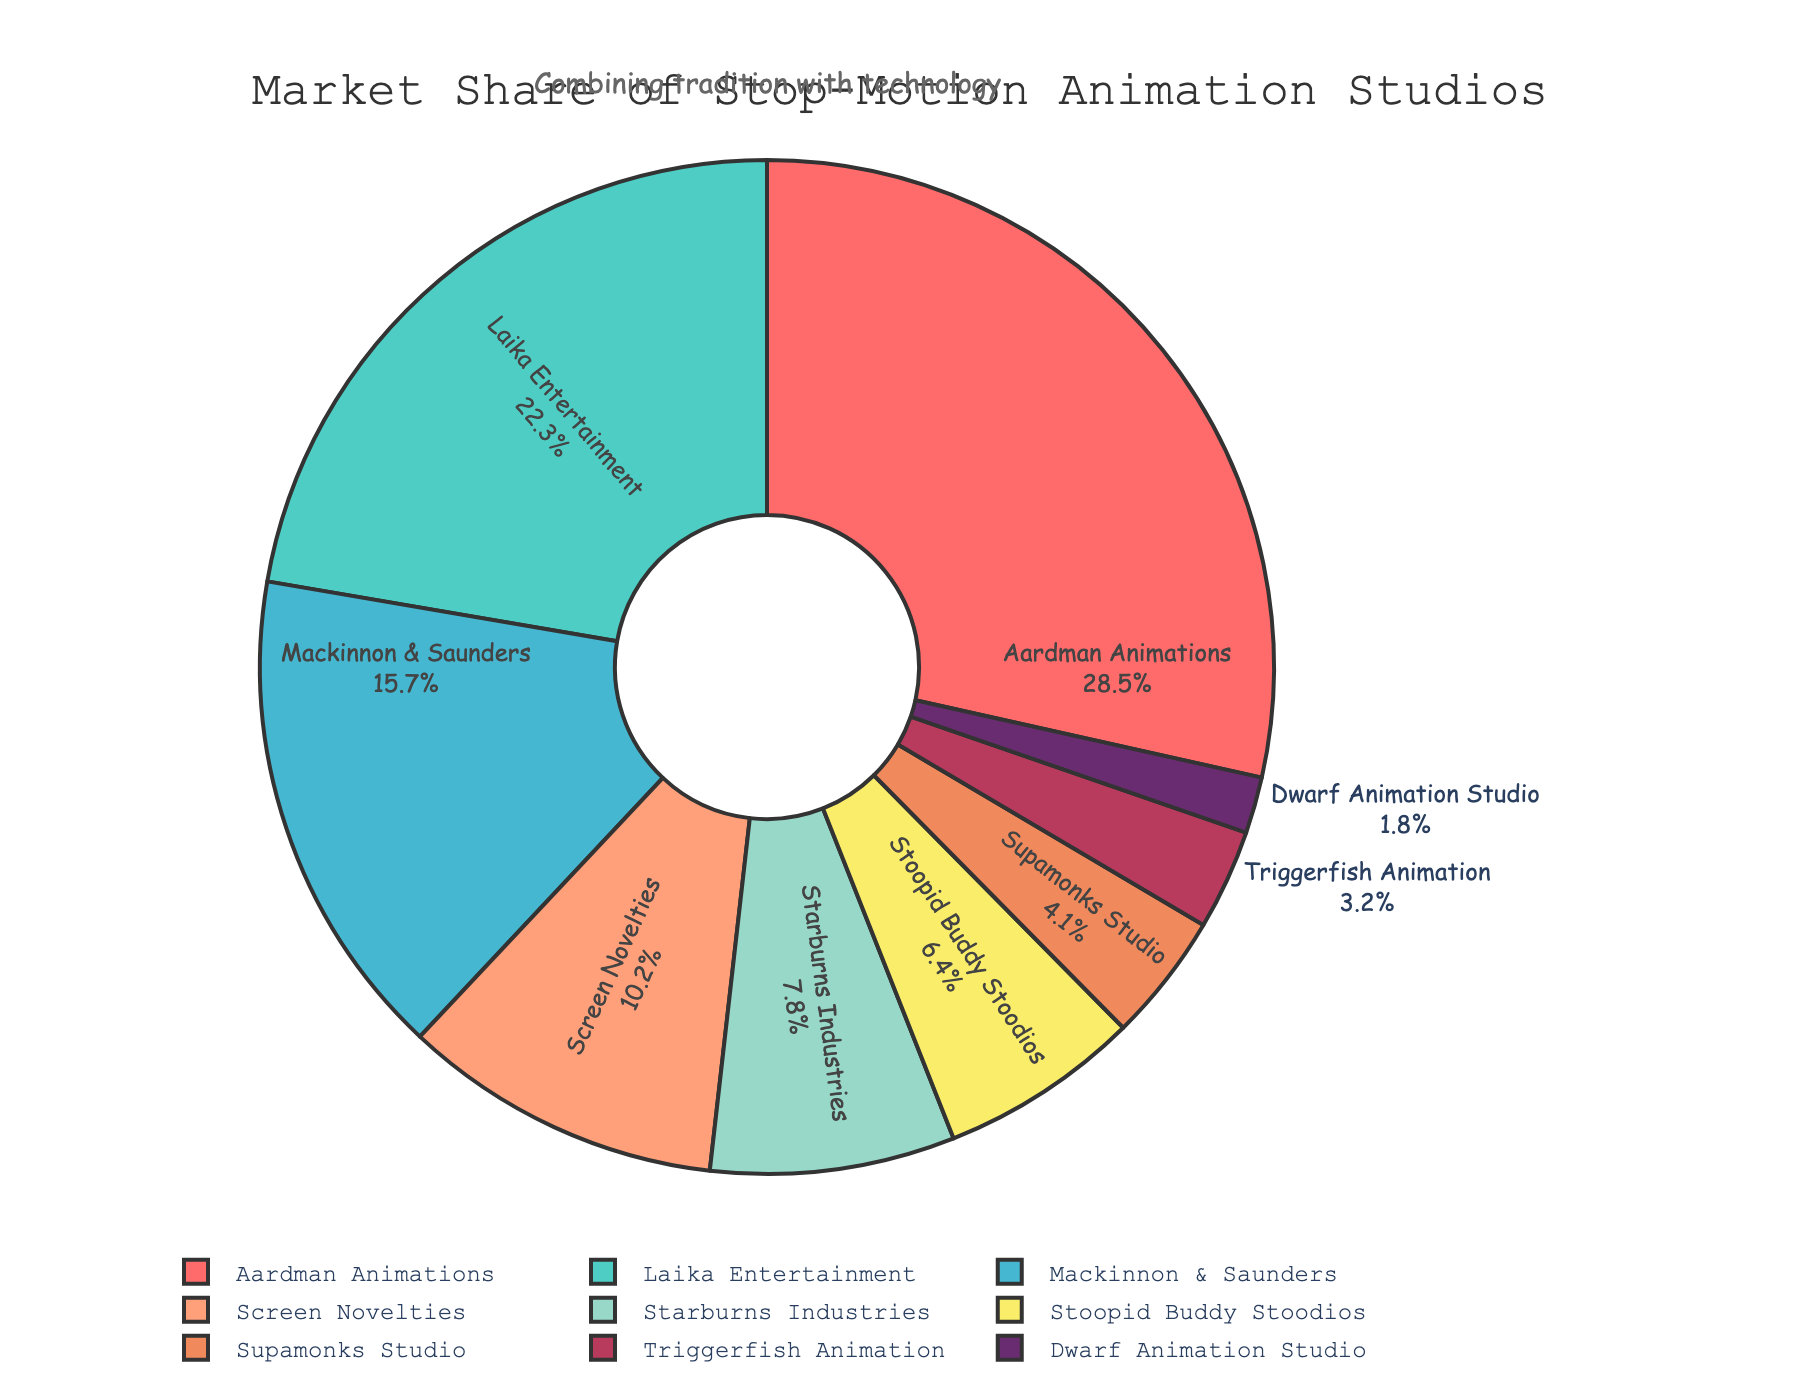What's the market share of the top studio? The top studio is Aardman Animations with a market share of 28.5%. This is directly shown in the pie chart by its label and percentage values.
Answer: 28.5% How much more market share does Laika Entertainment have compared to Mackinnon & Saunders? Laika Entertainment has a market share of 22.3%, while Mackinnon & Saunders has 15.7%. The difference is calculated as 22.3% - 15.7%.
Answer: 6.6% Which studios combined have a market share of over 50%? Adding up the market shares of the top studios until the sum exceeds 50%, we get: Aardman Animations (28.5%) + Laika Entertainment (22.3%) = 50.8%, which exceeds 50%. So, Aardman Animations and Laika Entertainment combined have over 50% market share.
Answer: Aardman Animations and Laika Entertainment What is the average market share of the studios listed? Adding up all the market shares: 28.5 + 22.3 + 15.7 + 10.2 + 7.8 + 6.4 + 4.1 + 3.2 + 1.8 = 100. Then, divide by the number of studios (9).
Answer: 100% ÷ 9 ≈ 11.11% Which studio has the smallest market share and what is it? The studio with the smallest market share is Dwarf Animation Studio, which has a market share of 1.8%. This can be directly observed from the smallest section and corresponding label on the pie chart.
Answer: Dwarf Animation Studio, 1.8% What is the combined market share of studios with less than 5% each? The studios with less than 5% market share are Supamonks Studio (4.1%), Triggerfish Animation (3.2%), and Dwarf Animation Studio (1.8%). Adding these up gives 4.1 + 3.2 + 1.8.
Answer: 4.1% + 3.2% + 1.8% = 9.1% How does the market share of Stoopid Buddy Stoodios compare to Supamonks Studio? Stoopid Buddy Stoodios has a market share of 6.4%, while Supamonks Studio has 4.1%. Stoopid Buddy Stoodios has a higher market share.
Answer: Stoopid Buddy Stoodios has a higher market share What is the total market share of the bottom three studios? The bottom three studios are Supamonks Studio (4.1%), Triggerfish Animation (3.2%), and Dwarf Animation Studio (1.8%). Adding these together gives 4.1 + 3.2 + 1.8.
Answer: 9.1% Which section of the pie chart is labeled with a yellow color? The studio labeled with a yellow color is F9ED69, which corresponds to Screen Novelties with a 10.2% market share. This color differentiation is clear in the pie chart section labeling.
Answer: Screen Novelties 